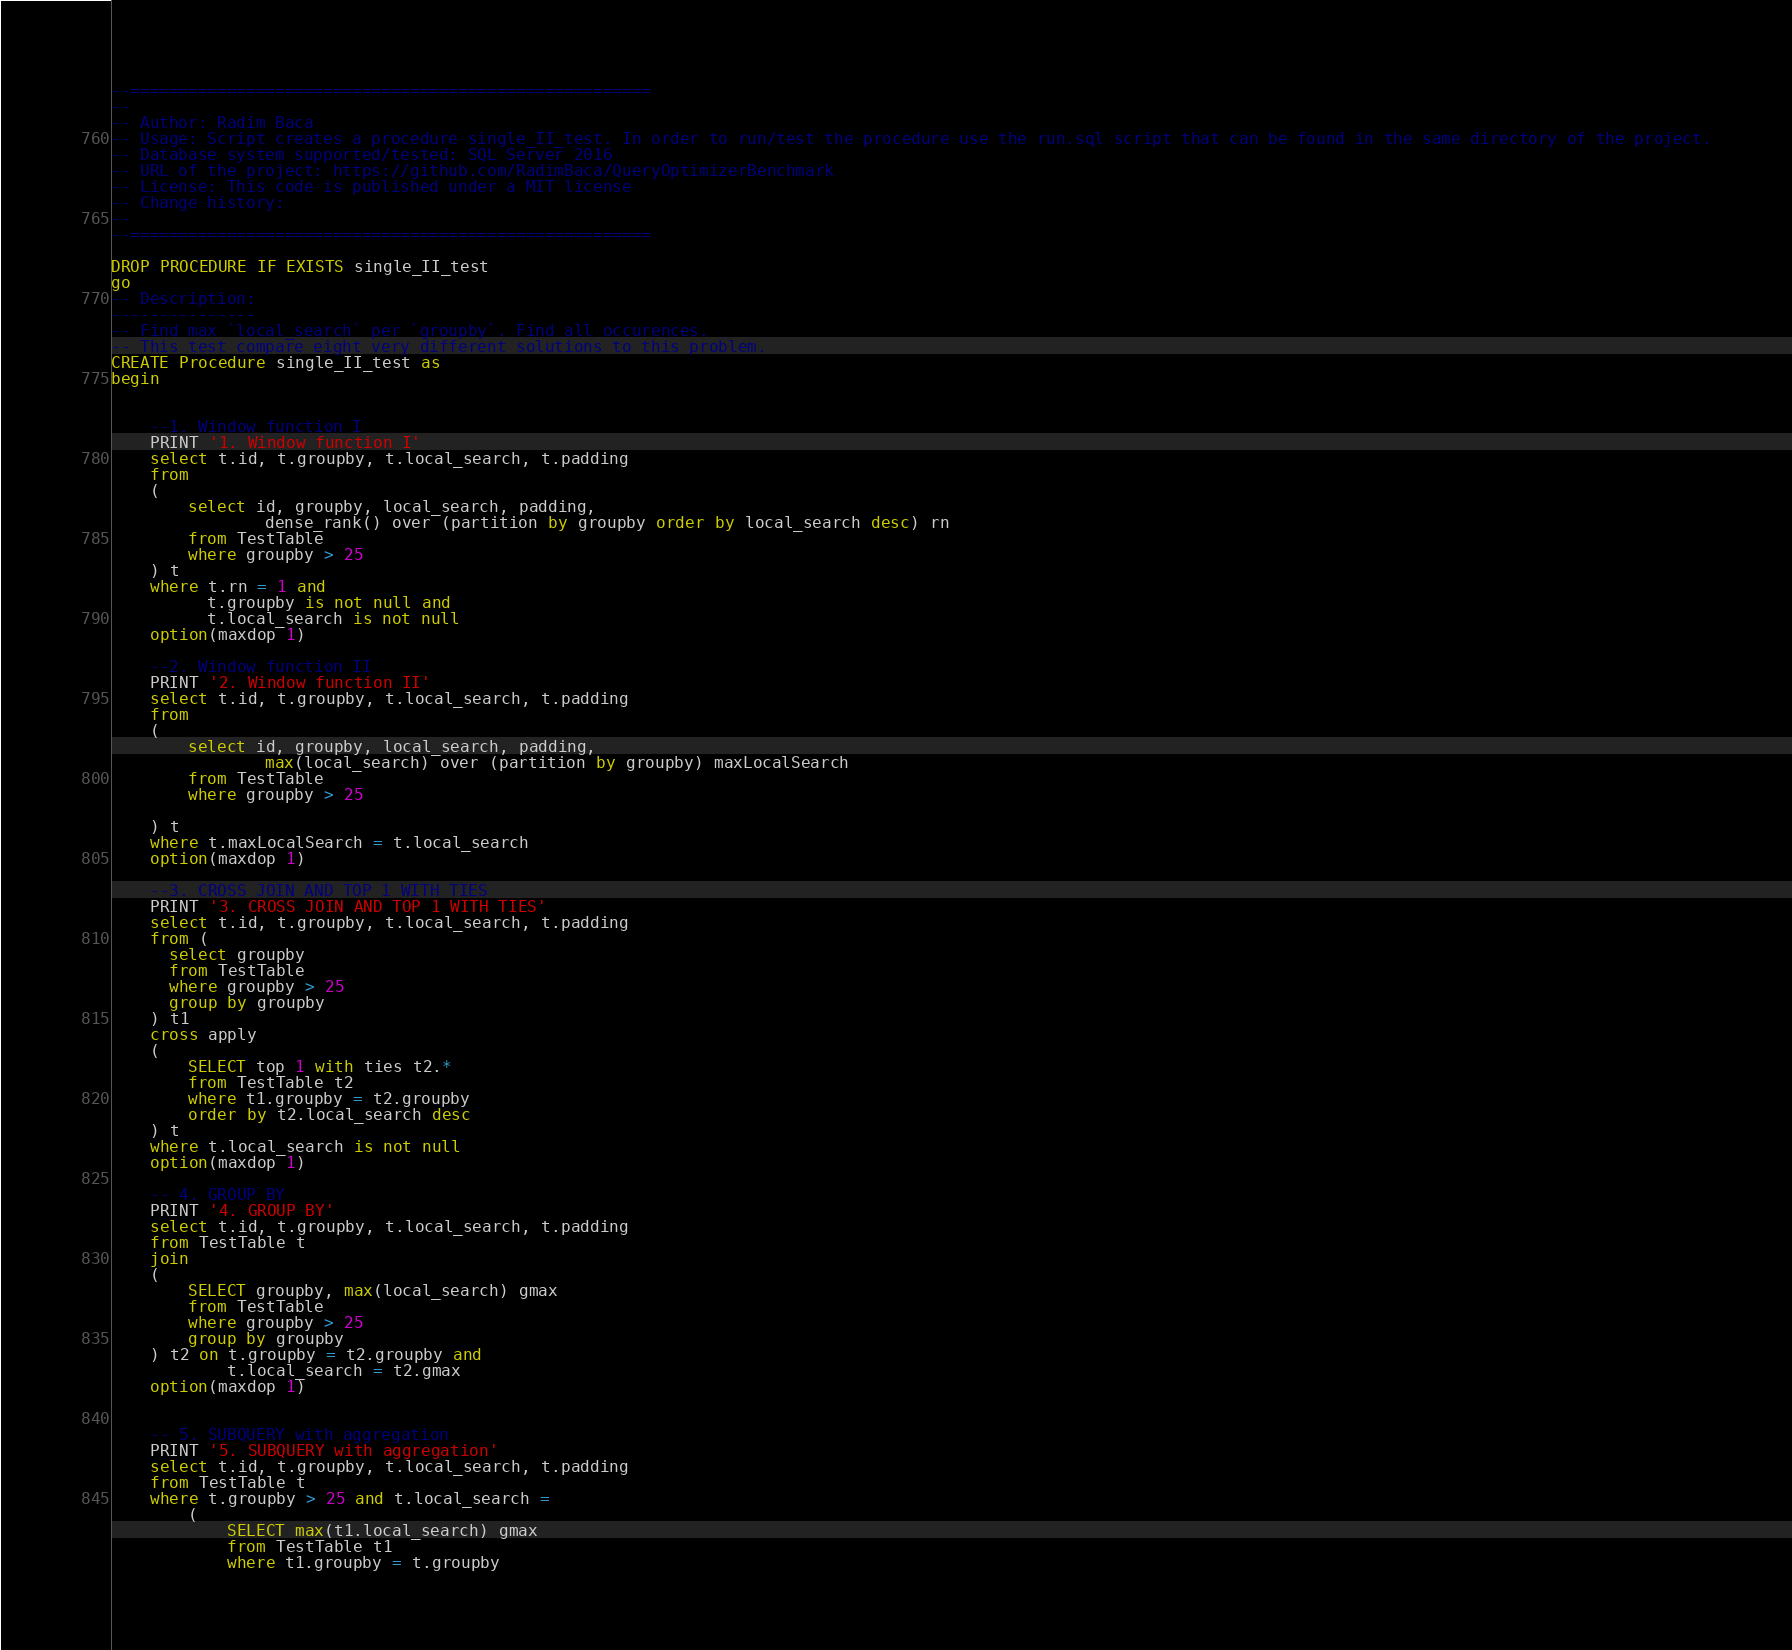Convert code to text. <code><loc_0><loc_0><loc_500><loc_500><_SQL_>--======================================================
--
-- Author: Radim Baca
-- Usage: Script creates a procedure single_II_test. In order to run/test the procedure use the run.sql script that can be found in the same directory of the project.
-- Database system supported/tested: SQL Server 2016
-- URL of the project: https://github.com/RadimBaca/QueryOptimizerBenchmark
-- License: This code is published under a MIT license
-- Change history:
--
--======================================================

DROP PROCEDURE IF EXISTS single_II_test
go
-- Description: 
---------------
-- Find max `local_search` per `groupby`. Find all occurences.
-- This test compare eight very different solutions to this problem.
CREATE Procedure single_II_test as
begin


	--1. Window function I
	PRINT '1. Window function I'
	select t.id, t.groupby, t.local_search, t.padding
	from
	(
		select id, groupby, local_search, padding, 
				dense_rank() over (partition by groupby order by local_search desc) rn
		from TestTable
		where groupby > 25
	) t
	where t.rn = 1 and 
	      t.groupby is not null and 
		  t.local_search is not null
	option(maxdop 1)

	--2. Window function II
	PRINT '2. Window function II'
	select t.id, t.groupby, t.local_search, t.padding
	from
	(
		select id, groupby, local_search, padding,
				max(local_search) over (partition by groupby) maxLocalSearch
		from TestTable 
		where groupby > 25

	) t
	where t.maxLocalSearch = t.local_search
	option(maxdop 1)

	--3. CROSS JOIN AND TOP 1 WITH TIES
	PRINT '3. CROSS JOIN AND TOP 1 WITH TIES'
	select t.id, t.groupby, t.local_search, t.padding
	from (
	  select groupby
	  from TestTable
	  where groupby > 25
	  group by groupby
	) t1
	cross apply
	(
		SELECT top 1 with ties t2.*
		from TestTable t2
		where t1.groupby = t2.groupby
		order by t2.local_search desc
	) t 
	where t.local_search is not null
	option(maxdop 1)

	-- 4. GROUP BY
	PRINT '4. GROUP BY'
	select t.id, t.groupby, t.local_search, t.padding
	from TestTable t
	join
	(
		SELECT groupby, max(local_search) gmax
		from TestTable
		where groupby > 25
		group by groupby
	) t2 on t.groupby = t2.groupby and 
	        t.local_search = t2.gmax
	option(maxdop 1)


	-- 5. SUBQUERY with aggregation
	PRINT '5. SUBQUERY with aggregation'
	select t.id, t.groupby, t.local_search, t.padding
	from TestTable t
	where t.groupby > 25 and t.local_search =
		(
			SELECT max(t1.local_search) gmax
			from TestTable t1
			where t1.groupby = t.groupby</code> 